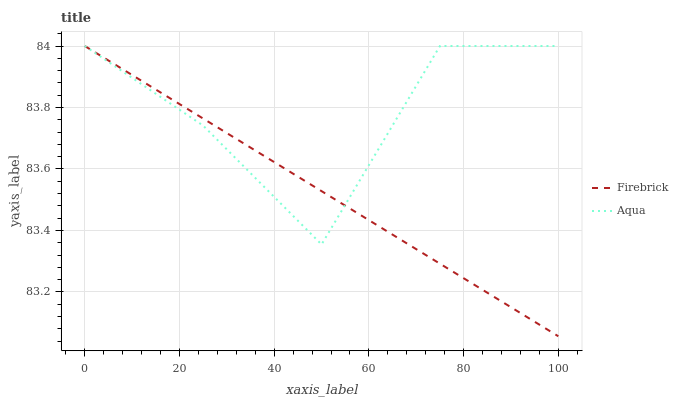Does Firebrick have the minimum area under the curve?
Answer yes or no. Yes. Does Aqua have the maximum area under the curve?
Answer yes or no. Yes. Does Aqua have the minimum area under the curve?
Answer yes or no. No. Is Firebrick the smoothest?
Answer yes or no. Yes. Is Aqua the roughest?
Answer yes or no. Yes. Is Aqua the smoothest?
Answer yes or no. No. Does Aqua have the lowest value?
Answer yes or no. No. 